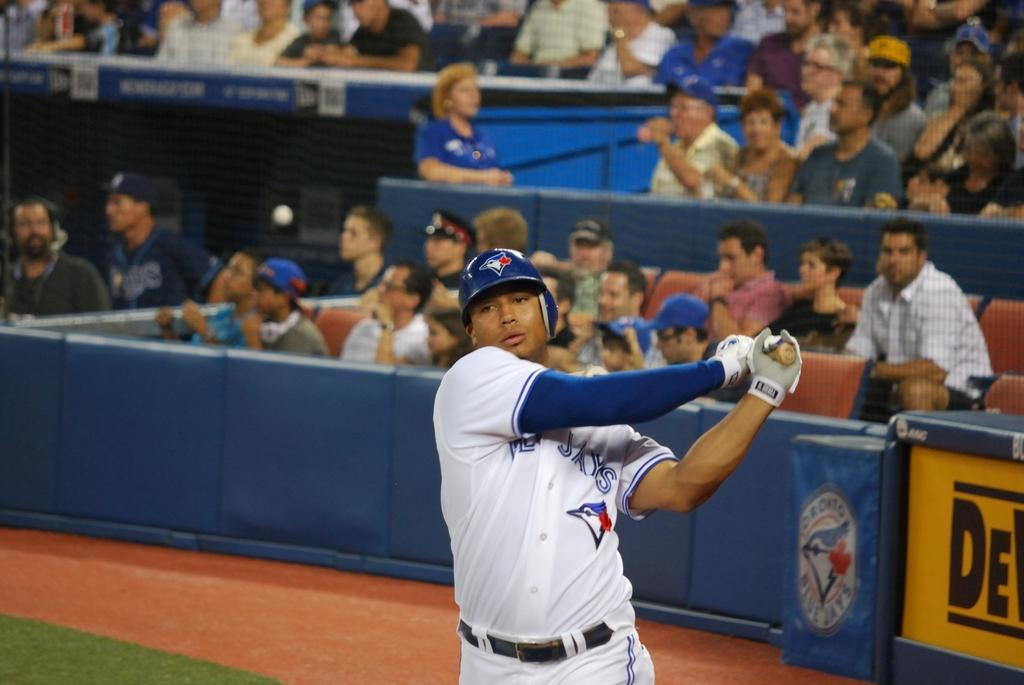<image>
Write a terse but informative summary of the picture. A member of the Toronto Blue Jays baseball team take a swing. 